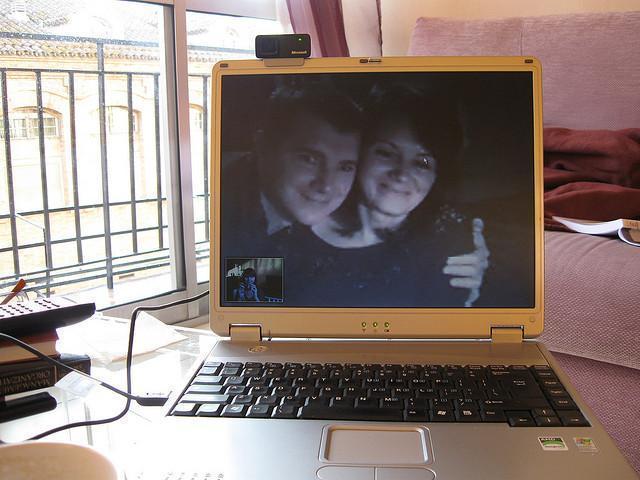Who is using this laptop?
Indicate the correct response by choosing from the four available options to answer the question.
Options: Girl, woman, man, boy. Girl. 